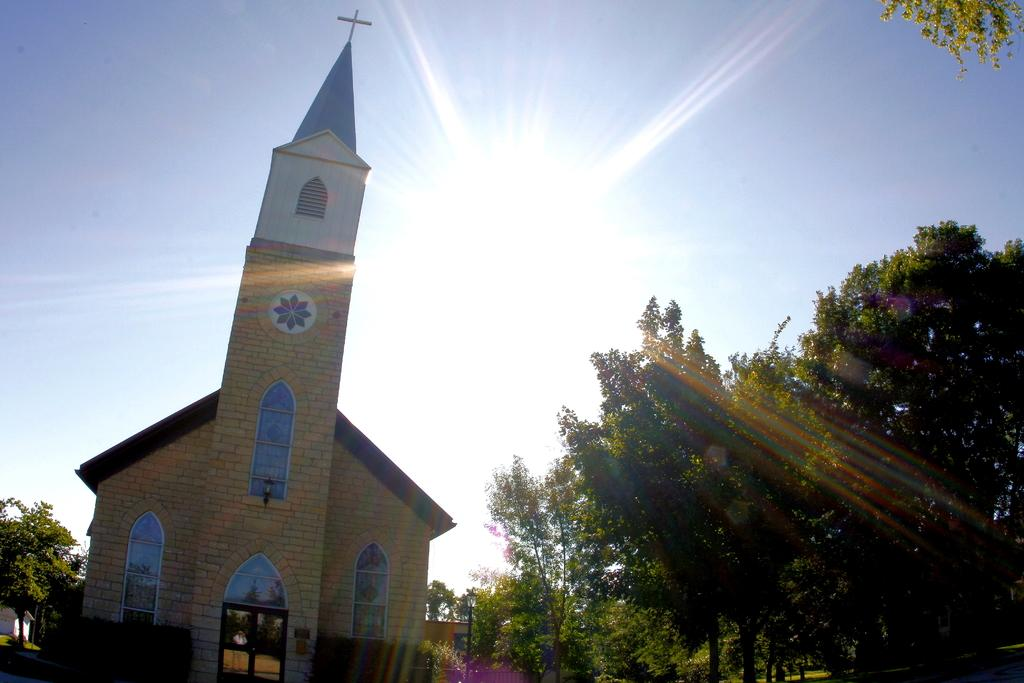What type of structure is in the image? There is a building in the image. What features can be seen on the building? The building has windows. What other objects are present in the image? There are trees, street poles, and a street light visible in the image. What can be seen in the sky? The sky is visible in the image, and the sun is observable. How many rings are visible on the pigs in the image? There are no pigs or rings present in the image. What type of profit can be seen in the image? There is no profit visible in the image; it features a building, trees, street poles, a street light, and the sky. 